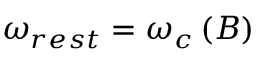<formula> <loc_0><loc_0><loc_500><loc_500>\begin{array} { r } { \omega _ { r e s t } = \omega _ { c } \left ( B \right ) } \end{array}</formula> 